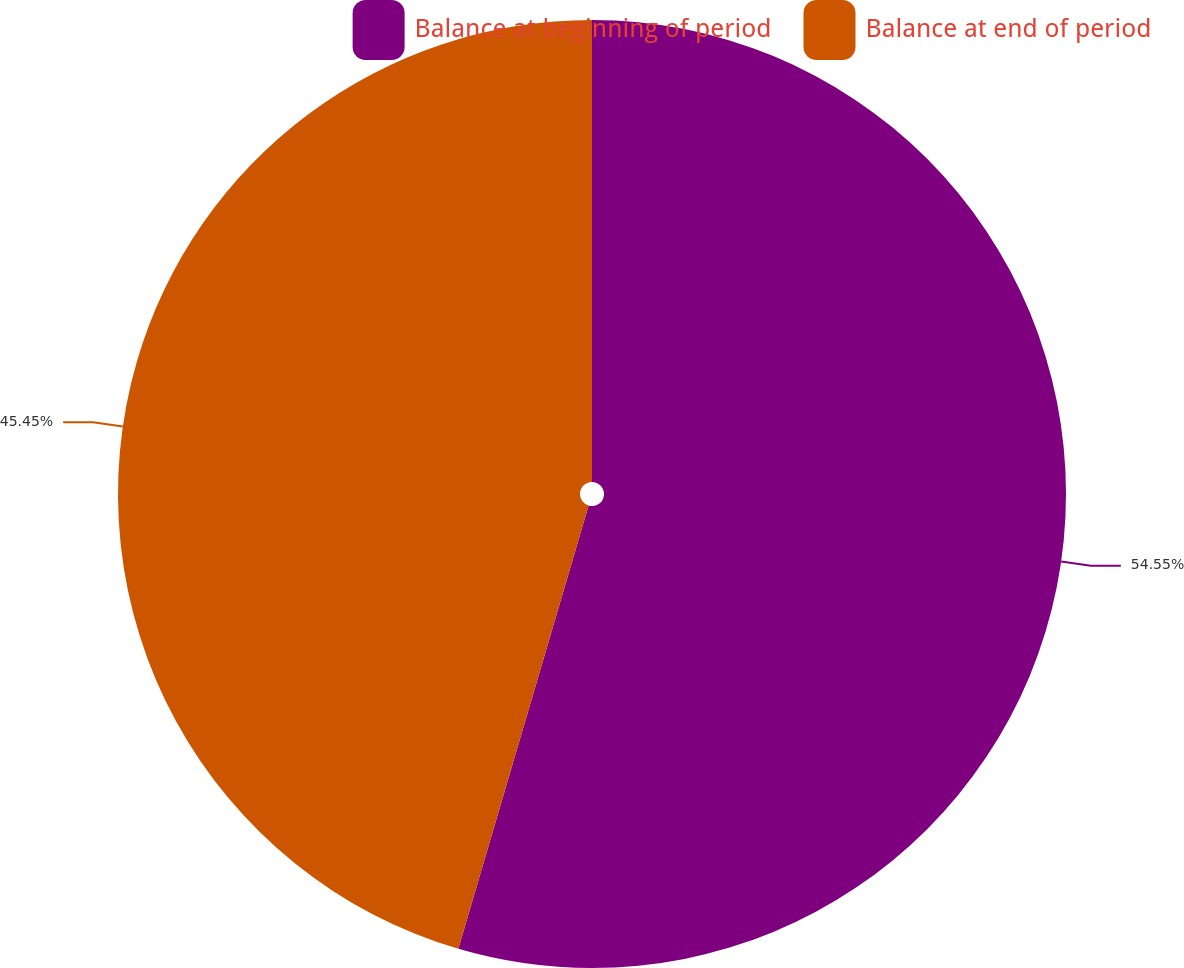Convert chart. <chart><loc_0><loc_0><loc_500><loc_500><pie_chart><fcel>Balance at beginning of period<fcel>Balance at end of period<nl><fcel>54.55%<fcel>45.45%<nl></chart> 